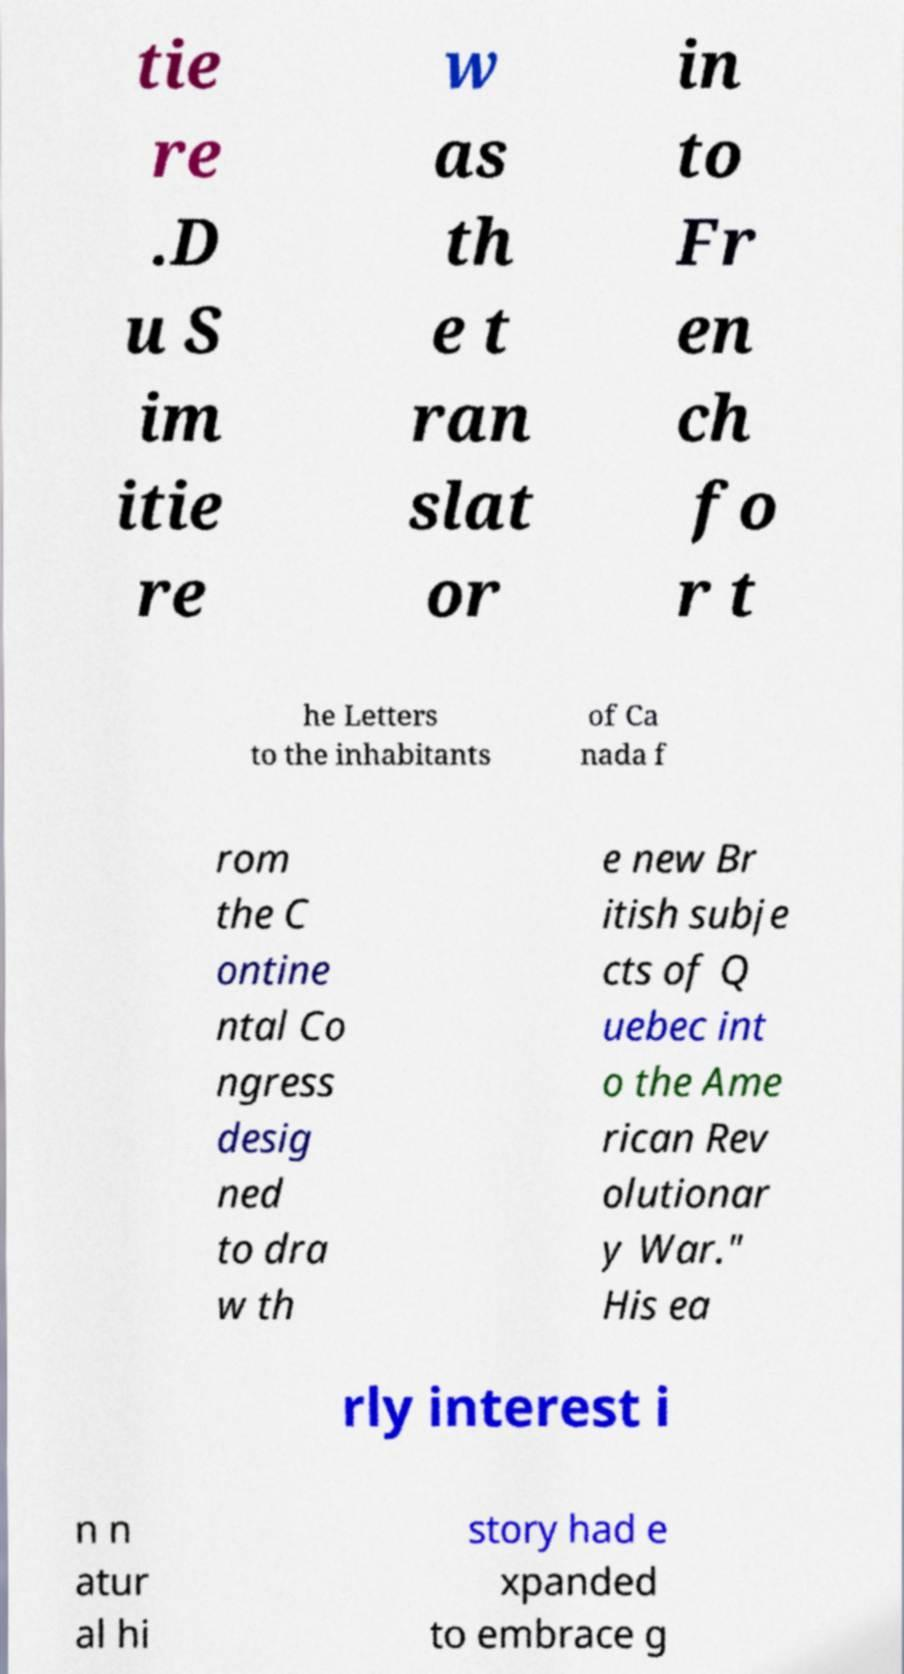Can you read and provide the text displayed in the image?This photo seems to have some interesting text. Can you extract and type it out for me? tie re .D u S im itie re w as th e t ran slat or in to Fr en ch fo r t he Letters to the inhabitants of Ca nada f rom the C ontine ntal Co ngress desig ned to dra w th e new Br itish subje cts of Q uebec int o the Ame rican Rev olutionar y War." His ea rly interest i n n atur al hi story had e xpanded to embrace g 